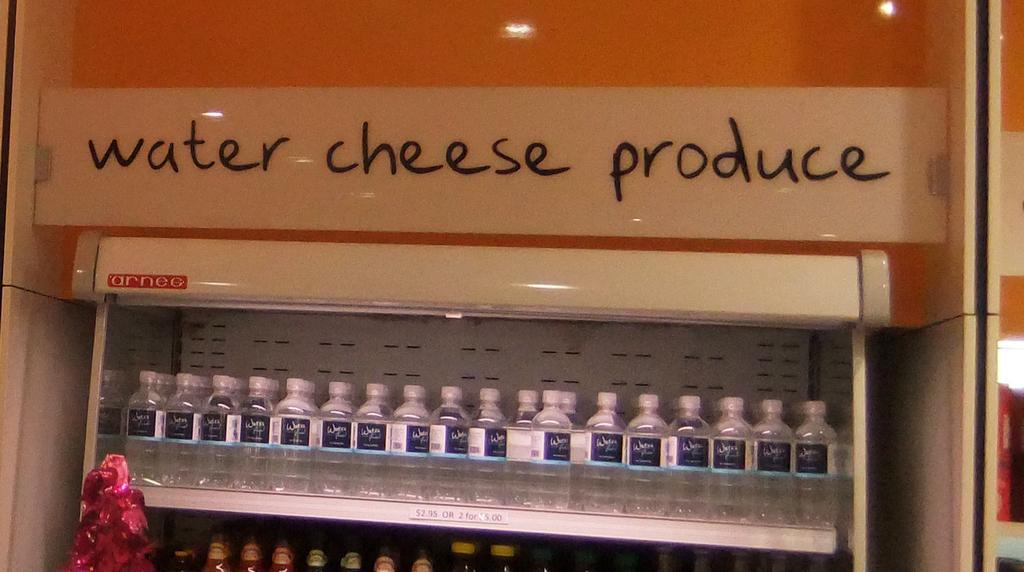Can you describe this image briefly? In the image we can see there are many bottles kept on the shelf and here we can see the text. 